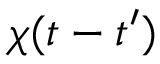<formula> <loc_0><loc_0><loc_500><loc_500>\chi ( t - t ^ { \prime } )</formula> 